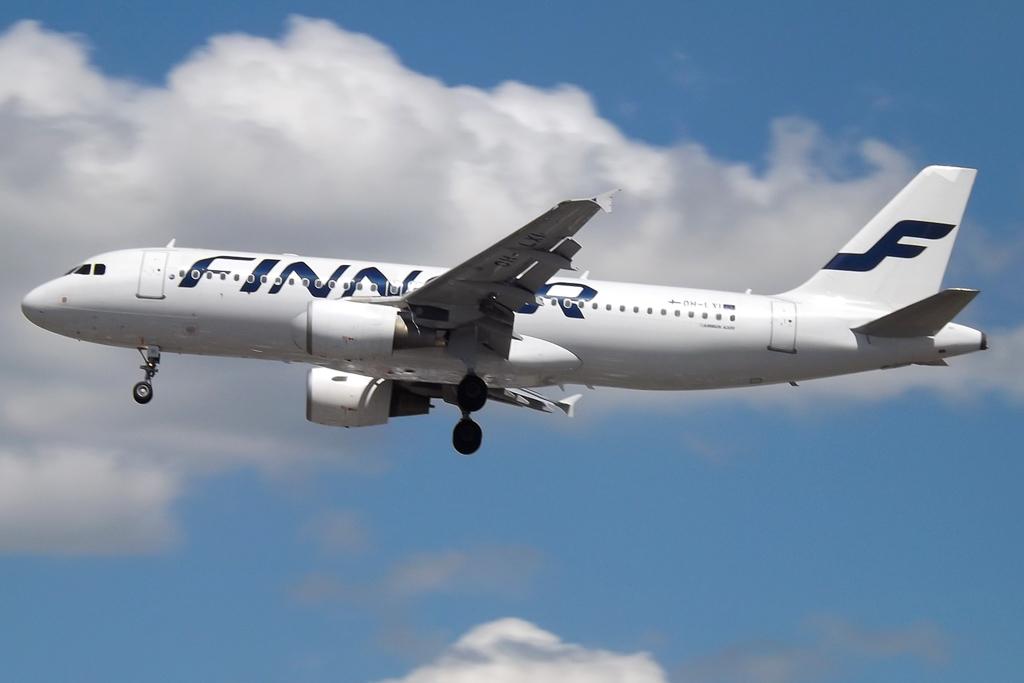What letter is on the plane's tail?
Your answer should be very brief. F. What airline is this?
Offer a very short reply. Finn. 